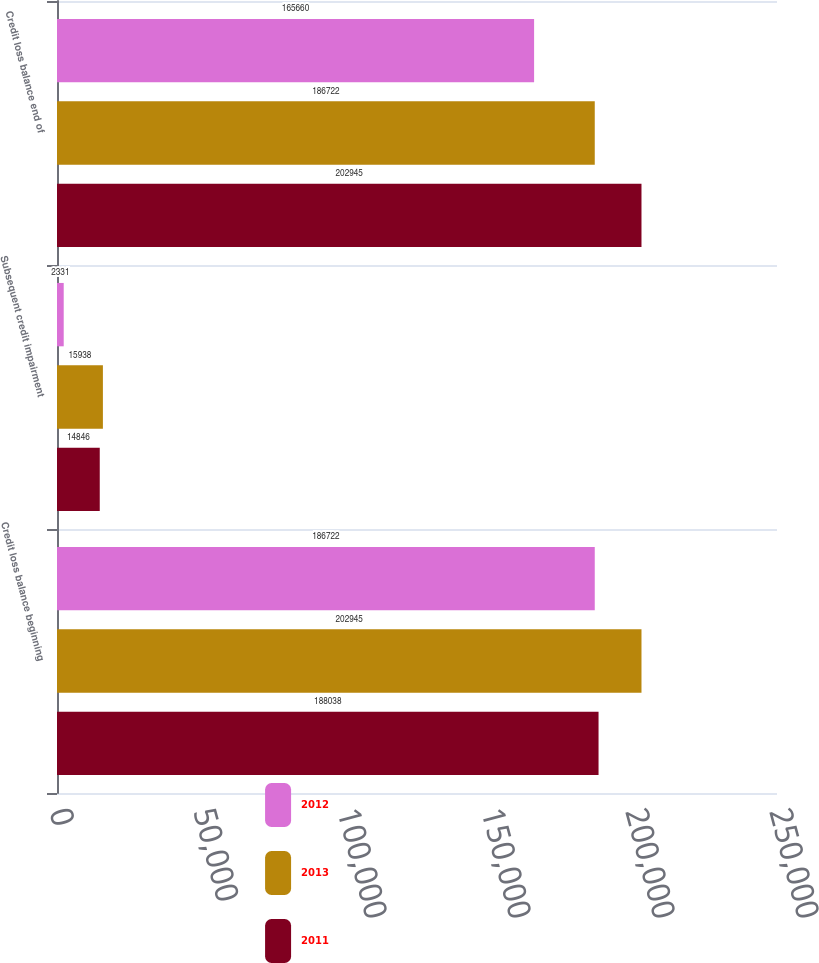Convert chart to OTSL. <chart><loc_0><loc_0><loc_500><loc_500><stacked_bar_chart><ecel><fcel>Credit loss balance beginning<fcel>Subsequent credit impairment<fcel>Credit loss balance end of<nl><fcel>2012<fcel>186722<fcel>2331<fcel>165660<nl><fcel>2013<fcel>202945<fcel>15938<fcel>186722<nl><fcel>2011<fcel>188038<fcel>14846<fcel>202945<nl></chart> 